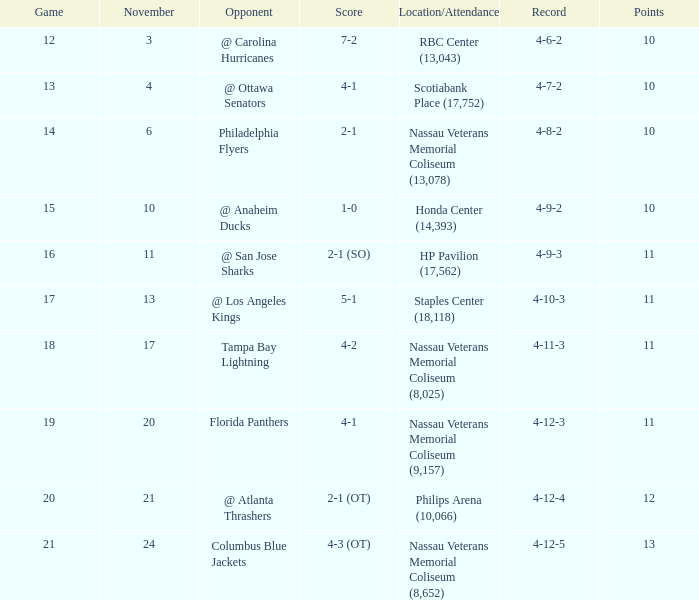What is the least amount of points? 10.0. 